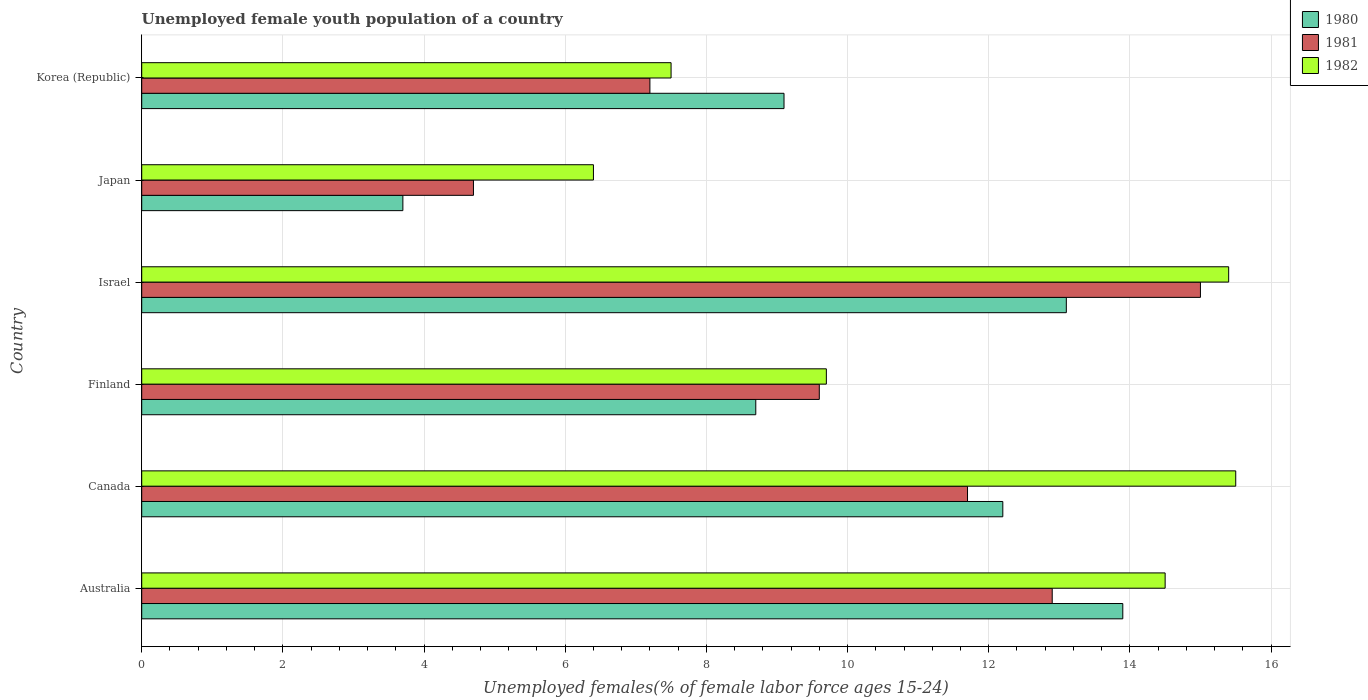How many different coloured bars are there?
Ensure brevity in your answer.  3. How many groups of bars are there?
Your response must be concise. 6. How many bars are there on the 3rd tick from the top?
Offer a very short reply. 3. How many bars are there on the 3rd tick from the bottom?
Your answer should be compact. 3. In how many cases, is the number of bars for a given country not equal to the number of legend labels?
Offer a terse response. 0. What is the percentage of unemployed female youth population in 1981 in Canada?
Offer a very short reply. 11.7. Across all countries, what is the maximum percentage of unemployed female youth population in 1980?
Your response must be concise. 13.9. Across all countries, what is the minimum percentage of unemployed female youth population in 1982?
Your answer should be compact. 6.4. In which country was the percentage of unemployed female youth population in 1982 minimum?
Your answer should be very brief. Japan. What is the total percentage of unemployed female youth population in 1982 in the graph?
Ensure brevity in your answer.  69. What is the difference between the percentage of unemployed female youth population in 1982 in Japan and that in Korea (Republic)?
Your response must be concise. -1.1. What is the difference between the percentage of unemployed female youth population in 1980 in Canada and the percentage of unemployed female youth population in 1982 in Korea (Republic)?
Offer a very short reply. 4.7. What is the average percentage of unemployed female youth population in 1981 per country?
Give a very brief answer. 10.18. In how many countries, is the percentage of unemployed female youth population in 1981 greater than 0.8 %?
Ensure brevity in your answer.  6. What is the ratio of the percentage of unemployed female youth population in 1980 in Japan to that in Korea (Republic)?
Your response must be concise. 0.41. Is the difference between the percentage of unemployed female youth population in 1980 in Canada and Israel greater than the difference between the percentage of unemployed female youth population in 1981 in Canada and Israel?
Provide a short and direct response. Yes. What is the difference between the highest and the second highest percentage of unemployed female youth population in 1982?
Your answer should be compact. 0.1. What is the difference between the highest and the lowest percentage of unemployed female youth population in 1980?
Your response must be concise. 10.2. In how many countries, is the percentage of unemployed female youth population in 1981 greater than the average percentage of unemployed female youth population in 1981 taken over all countries?
Offer a very short reply. 3. Is the sum of the percentage of unemployed female youth population in 1980 in Canada and Japan greater than the maximum percentage of unemployed female youth population in 1982 across all countries?
Offer a very short reply. Yes. What does the 2nd bar from the top in Israel represents?
Give a very brief answer. 1981. Is it the case that in every country, the sum of the percentage of unemployed female youth population in 1980 and percentage of unemployed female youth population in 1982 is greater than the percentage of unemployed female youth population in 1981?
Offer a terse response. Yes. How many bars are there?
Give a very brief answer. 18. How many countries are there in the graph?
Ensure brevity in your answer.  6. Are the values on the major ticks of X-axis written in scientific E-notation?
Keep it short and to the point. No. Does the graph contain any zero values?
Your response must be concise. No. What is the title of the graph?
Keep it short and to the point. Unemployed female youth population of a country. What is the label or title of the X-axis?
Your answer should be very brief. Unemployed females(% of female labor force ages 15-24). What is the Unemployed females(% of female labor force ages 15-24) in 1980 in Australia?
Ensure brevity in your answer.  13.9. What is the Unemployed females(% of female labor force ages 15-24) in 1981 in Australia?
Offer a very short reply. 12.9. What is the Unemployed females(% of female labor force ages 15-24) in 1980 in Canada?
Your answer should be compact. 12.2. What is the Unemployed females(% of female labor force ages 15-24) in 1981 in Canada?
Give a very brief answer. 11.7. What is the Unemployed females(% of female labor force ages 15-24) in 1982 in Canada?
Provide a short and direct response. 15.5. What is the Unemployed females(% of female labor force ages 15-24) of 1980 in Finland?
Provide a succinct answer. 8.7. What is the Unemployed females(% of female labor force ages 15-24) in 1981 in Finland?
Make the answer very short. 9.6. What is the Unemployed females(% of female labor force ages 15-24) of 1982 in Finland?
Your response must be concise. 9.7. What is the Unemployed females(% of female labor force ages 15-24) in 1980 in Israel?
Offer a terse response. 13.1. What is the Unemployed females(% of female labor force ages 15-24) in 1981 in Israel?
Ensure brevity in your answer.  15. What is the Unemployed females(% of female labor force ages 15-24) of 1982 in Israel?
Give a very brief answer. 15.4. What is the Unemployed females(% of female labor force ages 15-24) in 1980 in Japan?
Your response must be concise. 3.7. What is the Unemployed females(% of female labor force ages 15-24) of 1981 in Japan?
Your answer should be compact. 4.7. What is the Unemployed females(% of female labor force ages 15-24) in 1982 in Japan?
Your answer should be compact. 6.4. What is the Unemployed females(% of female labor force ages 15-24) of 1980 in Korea (Republic)?
Provide a succinct answer. 9.1. What is the Unemployed females(% of female labor force ages 15-24) of 1981 in Korea (Republic)?
Provide a short and direct response. 7.2. What is the Unemployed females(% of female labor force ages 15-24) in 1982 in Korea (Republic)?
Keep it short and to the point. 7.5. Across all countries, what is the maximum Unemployed females(% of female labor force ages 15-24) in 1980?
Make the answer very short. 13.9. Across all countries, what is the maximum Unemployed females(% of female labor force ages 15-24) of 1981?
Your response must be concise. 15. Across all countries, what is the maximum Unemployed females(% of female labor force ages 15-24) in 1982?
Offer a very short reply. 15.5. Across all countries, what is the minimum Unemployed females(% of female labor force ages 15-24) of 1980?
Your answer should be compact. 3.7. Across all countries, what is the minimum Unemployed females(% of female labor force ages 15-24) of 1981?
Your answer should be compact. 4.7. Across all countries, what is the minimum Unemployed females(% of female labor force ages 15-24) in 1982?
Your answer should be very brief. 6.4. What is the total Unemployed females(% of female labor force ages 15-24) of 1980 in the graph?
Offer a terse response. 60.7. What is the total Unemployed females(% of female labor force ages 15-24) of 1981 in the graph?
Give a very brief answer. 61.1. What is the difference between the Unemployed females(% of female labor force ages 15-24) in 1980 in Australia and that in Canada?
Provide a succinct answer. 1.7. What is the difference between the Unemployed females(% of female labor force ages 15-24) of 1982 in Australia and that in Canada?
Provide a succinct answer. -1. What is the difference between the Unemployed females(% of female labor force ages 15-24) in 1982 in Australia and that in Finland?
Provide a short and direct response. 4.8. What is the difference between the Unemployed females(% of female labor force ages 15-24) of 1980 in Australia and that in Israel?
Your answer should be compact. 0.8. What is the difference between the Unemployed females(% of female labor force ages 15-24) of 1981 in Australia and that in Israel?
Your answer should be very brief. -2.1. What is the difference between the Unemployed females(% of female labor force ages 15-24) of 1982 in Australia and that in Israel?
Offer a very short reply. -0.9. What is the difference between the Unemployed females(% of female labor force ages 15-24) in 1980 in Australia and that in Japan?
Your answer should be very brief. 10.2. What is the difference between the Unemployed females(% of female labor force ages 15-24) of 1980 in Australia and that in Korea (Republic)?
Offer a very short reply. 4.8. What is the difference between the Unemployed females(% of female labor force ages 15-24) in 1981 in Australia and that in Korea (Republic)?
Offer a very short reply. 5.7. What is the difference between the Unemployed females(% of female labor force ages 15-24) in 1982 in Australia and that in Korea (Republic)?
Provide a short and direct response. 7. What is the difference between the Unemployed females(% of female labor force ages 15-24) in 1980 in Canada and that in Finland?
Your response must be concise. 3.5. What is the difference between the Unemployed females(% of female labor force ages 15-24) of 1980 in Canada and that in Israel?
Ensure brevity in your answer.  -0.9. What is the difference between the Unemployed females(% of female labor force ages 15-24) in 1980 in Canada and that in Japan?
Give a very brief answer. 8.5. What is the difference between the Unemployed females(% of female labor force ages 15-24) of 1981 in Canada and that in Korea (Republic)?
Your answer should be very brief. 4.5. What is the difference between the Unemployed females(% of female labor force ages 15-24) in 1980 in Finland and that in Israel?
Make the answer very short. -4.4. What is the difference between the Unemployed females(% of female labor force ages 15-24) in 1981 in Finland and that in Israel?
Make the answer very short. -5.4. What is the difference between the Unemployed females(% of female labor force ages 15-24) in 1980 in Finland and that in Japan?
Your response must be concise. 5. What is the difference between the Unemployed females(% of female labor force ages 15-24) of 1981 in Finland and that in Japan?
Give a very brief answer. 4.9. What is the difference between the Unemployed females(% of female labor force ages 15-24) in 1982 in Finland and that in Japan?
Make the answer very short. 3.3. What is the difference between the Unemployed females(% of female labor force ages 15-24) in 1982 in Finland and that in Korea (Republic)?
Your response must be concise. 2.2. What is the difference between the Unemployed females(% of female labor force ages 15-24) of 1980 in Israel and that in Japan?
Keep it short and to the point. 9.4. What is the difference between the Unemployed females(% of female labor force ages 15-24) in 1980 in Japan and that in Korea (Republic)?
Your answer should be compact. -5.4. What is the difference between the Unemployed females(% of female labor force ages 15-24) of 1981 in Japan and that in Korea (Republic)?
Offer a terse response. -2.5. What is the difference between the Unemployed females(% of female labor force ages 15-24) in 1982 in Japan and that in Korea (Republic)?
Offer a very short reply. -1.1. What is the difference between the Unemployed females(% of female labor force ages 15-24) in 1980 in Australia and the Unemployed females(% of female labor force ages 15-24) in 1981 in Finland?
Keep it short and to the point. 4.3. What is the difference between the Unemployed females(% of female labor force ages 15-24) in 1981 in Australia and the Unemployed females(% of female labor force ages 15-24) in 1982 in Finland?
Provide a succinct answer. 3.2. What is the difference between the Unemployed females(% of female labor force ages 15-24) of 1981 in Australia and the Unemployed females(% of female labor force ages 15-24) of 1982 in Israel?
Provide a short and direct response. -2.5. What is the difference between the Unemployed females(% of female labor force ages 15-24) in 1980 in Australia and the Unemployed females(% of female labor force ages 15-24) in 1981 in Korea (Republic)?
Give a very brief answer. 6.7. What is the difference between the Unemployed females(% of female labor force ages 15-24) in 1980 in Australia and the Unemployed females(% of female labor force ages 15-24) in 1982 in Korea (Republic)?
Ensure brevity in your answer.  6.4. What is the difference between the Unemployed females(% of female labor force ages 15-24) in 1980 in Canada and the Unemployed females(% of female labor force ages 15-24) in 1981 in Finland?
Your response must be concise. 2.6. What is the difference between the Unemployed females(% of female labor force ages 15-24) in 1980 in Canada and the Unemployed females(% of female labor force ages 15-24) in 1982 in Finland?
Your answer should be compact. 2.5. What is the difference between the Unemployed females(% of female labor force ages 15-24) in 1981 in Canada and the Unemployed females(% of female labor force ages 15-24) in 1982 in Finland?
Your response must be concise. 2. What is the difference between the Unemployed females(% of female labor force ages 15-24) in 1980 in Canada and the Unemployed females(% of female labor force ages 15-24) in 1982 in Israel?
Offer a very short reply. -3.2. What is the difference between the Unemployed females(% of female labor force ages 15-24) of 1981 in Canada and the Unemployed females(% of female labor force ages 15-24) of 1982 in Israel?
Your response must be concise. -3.7. What is the difference between the Unemployed females(% of female labor force ages 15-24) in 1980 in Canada and the Unemployed females(% of female labor force ages 15-24) in 1981 in Japan?
Your response must be concise. 7.5. What is the difference between the Unemployed females(% of female labor force ages 15-24) in 1980 in Canada and the Unemployed females(% of female labor force ages 15-24) in 1982 in Japan?
Keep it short and to the point. 5.8. What is the difference between the Unemployed females(% of female labor force ages 15-24) in 1981 in Canada and the Unemployed females(% of female labor force ages 15-24) in 1982 in Japan?
Your response must be concise. 5.3. What is the difference between the Unemployed females(% of female labor force ages 15-24) in 1980 in Canada and the Unemployed females(% of female labor force ages 15-24) in 1982 in Korea (Republic)?
Offer a very short reply. 4.7. What is the difference between the Unemployed females(% of female labor force ages 15-24) in 1980 in Finland and the Unemployed females(% of female labor force ages 15-24) in 1981 in Israel?
Your answer should be very brief. -6.3. What is the difference between the Unemployed females(% of female labor force ages 15-24) in 1980 in Finland and the Unemployed females(% of female labor force ages 15-24) in 1982 in Israel?
Your answer should be very brief. -6.7. What is the difference between the Unemployed females(% of female labor force ages 15-24) in 1980 in Finland and the Unemployed females(% of female labor force ages 15-24) in 1982 in Japan?
Keep it short and to the point. 2.3. What is the difference between the Unemployed females(% of female labor force ages 15-24) in 1980 in Finland and the Unemployed females(% of female labor force ages 15-24) in 1982 in Korea (Republic)?
Your answer should be very brief. 1.2. What is the difference between the Unemployed females(% of female labor force ages 15-24) of 1980 in Israel and the Unemployed females(% of female labor force ages 15-24) of 1982 in Japan?
Offer a very short reply. 6.7. What is the difference between the Unemployed females(% of female labor force ages 15-24) in 1980 in Israel and the Unemployed females(% of female labor force ages 15-24) in 1982 in Korea (Republic)?
Provide a succinct answer. 5.6. What is the difference between the Unemployed females(% of female labor force ages 15-24) in 1981 in Japan and the Unemployed females(% of female labor force ages 15-24) in 1982 in Korea (Republic)?
Give a very brief answer. -2.8. What is the average Unemployed females(% of female labor force ages 15-24) of 1980 per country?
Your answer should be very brief. 10.12. What is the average Unemployed females(% of female labor force ages 15-24) in 1981 per country?
Your response must be concise. 10.18. What is the average Unemployed females(% of female labor force ages 15-24) of 1982 per country?
Keep it short and to the point. 11.5. What is the difference between the Unemployed females(% of female labor force ages 15-24) in 1980 and Unemployed females(% of female labor force ages 15-24) in 1981 in Australia?
Your response must be concise. 1. What is the difference between the Unemployed females(% of female labor force ages 15-24) in 1980 and Unemployed females(% of female labor force ages 15-24) in 1982 in Australia?
Your answer should be compact. -0.6. What is the difference between the Unemployed females(% of female labor force ages 15-24) in 1980 and Unemployed females(% of female labor force ages 15-24) in 1981 in Canada?
Your answer should be very brief. 0.5. What is the difference between the Unemployed females(% of female labor force ages 15-24) of 1980 and Unemployed females(% of female labor force ages 15-24) of 1982 in Canada?
Provide a short and direct response. -3.3. What is the difference between the Unemployed females(% of female labor force ages 15-24) in 1981 and Unemployed females(% of female labor force ages 15-24) in 1982 in Canada?
Make the answer very short. -3.8. What is the difference between the Unemployed females(% of female labor force ages 15-24) in 1980 and Unemployed females(% of female labor force ages 15-24) in 1981 in Finland?
Offer a terse response. -0.9. What is the difference between the Unemployed females(% of female labor force ages 15-24) of 1980 and Unemployed females(% of female labor force ages 15-24) of 1982 in Finland?
Provide a succinct answer. -1. What is the difference between the Unemployed females(% of female labor force ages 15-24) of 1980 and Unemployed females(% of female labor force ages 15-24) of 1981 in Israel?
Your response must be concise. -1.9. What is the difference between the Unemployed females(% of female labor force ages 15-24) of 1980 and Unemployed females(% of female labor force ages 15-24) of 1982 in Israel?
Your answer should be compact. -2.3. What is the difference between the Unemployed females(% of female labor force ages 15-24) of 1981 and Unemployed females(% of female labor force ages 15-24) of 1982 in Israel?
Offer a terse response. -0.4. What is the difference between the Unemployed females(% of female labor force ages 15-24) of 1980 and Unemployed females(% of female labor force ages 15-24) of 1981 in Japan?
Your answer should be very brief. -1. What is the difference between the Unemployed females(% of female labor force ages 15-24) of 1981 and Unemployed females(% of female labor force ages 15-24) of 1982 in Japan?
Ensure brevity in your answer.  -1.7. What is the difference between the Unemployed females(% of female labor force ages 15-24) of 1980 and Unemployed females(% of female labor force ages 15-24) of 1981 in Korea (Republic)?
Keep it short and to the point. 1.9. What is the difference between the Unemployed females(% of female labor force ages 15-24) of 1980 and Unemployed females(% of female labor force ages 15-24) of 1982 in Korea (Republic)?
Offer a very short reply. 1.6. What is the difference between the Unemployed females(% of female labor force ages 15-24) in 1981 and Unemployed females(% of female labor force ages 15-24) in 1982 in Korea (Republic)?
Keep it short and to the point. -0.3. What is the ratio of the Unemployed females(% of female labor force ages 15-24) in 1980 in Australia to that in Canada?
Provide a short and direct response. 1.14. What is the ratio of the Unemployed females(% of female labor force ages 15-24) of 1981 in Australia to that in Canada?
Your response must be concise. 1.1. What is the ratio of the Unemployed females(% of female labor force ages 15-24) in 1982 in Australia to that in Canada?
Keep it short and to the point. 0.94. What is the ratio of the Unemployed females(% of female labor force ages 15-24) of 1980 in Australia to that in Finland?
Provide a succinct answer. 1.6. What is the ratio of the Unemployed females(% of female labor force ages 15-24) in 1981 in Australia to that in Finland?
Provide a succinct answer. 1.34. What is the ratio of the Unemployed females(% of female labor force ages 15-24) of 1982 in Australia to that in Finland?
Your response must be concise. 1.49. What is the ratio of the Unemployed females(% of female labor force ages 15-24) of 1980 in Australia to that in Israel?
Make the answer very short. 1.06. What is the ratio of the Unemployed females(% of female labor force ages 15-24) in 1981 in Australia to that in Israel?
Provide a short and direct response. 0.86. What is the ratio of the Unemployed females(% of female labor force ages 15-24) in 1982 in Australia to that in Israel?
Provide a short and direct response. 0.94. What is the ratio of the Unemployed females(% of female labor force ages 15-24) in 1980 in Australia to that in Japan?
Give a very brief answer. 3.76. What is the ratio of the Unemployed females(% of female labor force ages 15-24) in 1981 in Australia to that in Japan?
Offer a terse response. 2.74. What is the ratio of the Unemployed females(% of female labor force ages 15-24) in 1982 in Australia to that in Japan?
Your response must be concise. 2.27. What is the ratio of the Unemployed females(% of female labor force ages 15-24) in 1980 in Australia to that in Korea (Republic)?
Provide a short and direct response. 1.53. What is the ratio of the Unemployed females(% of female labor force ages 15-24) of 1981 in Australia to that in Korea (Republic)?
Make the answer very short. 1.79. What is the ratio of the Unemployed females(% of female labor force ages 15-24) in 1982 in Australia to that in Korea (Republic)?
Your response must be concise. 1.93. What is the ratio of the Unemployed females(% of female labor force ages 15-24) in 1980 in Canada to that in Finland?
Make the answer very short. 1.4. What is the ratio of the Unemployed females(% of female labor force ages 15-24) of 1981 in Canada to that in Finland?
Provide a succinct answer. 1.22. What is the ratio of the Unemployed females(% of female labor force ages 15-24) in 1982 in Canada to that in Finland?
Keep it short and to the point. 1.6. What is the ratio of the Unemployed females(% of female labor force ages 15-24) in 1980 in Canada to that in Israel?
Your answer should be very brief. 0.93. What is the ratio of the Unemployed females(% of female labor force ages 15-24) in 1981 in Canada to that in Israel?
Keep it short and to the point. 0.78. What is the ratio of the Unemployed females(% of female labor force ages 15-24) of 1982 in Canada to that in Israel?
Make the answer very short. 1.01. What is the ratio of the Unemployed females(% of female labor force ages 15-24) in 1980 in Canada to that in Japan?
Your answer should be compact. 3.3. What is the ratio of the Unemployed females(% of female labor force ages 15-24) in 1981 in Canada to that in Japan?
Your response must be concise. 2.49. What is the ratio of the Unemployed females(% of female labor force ages 15-24) in 1982 in Canada to that in Japan?
Provide a short and direct response. 2.42. What is the ratio of the Unemployed females(% of female labor force ages 15-24) of 1980 in Canada to that in Korea (Republic)?
Offer a terse response. 1.34. What is the ratio of the Unemployed females(% of female labor force ages 15-24) of 1981 in Canada to that in Korea (Republic)?
Provide a succinct answer. 1.62. What is the ratio of the Unemployed females(% of female labor force ages 15-24) of 1982 in Canada to that in Korea (Republic)?
Ensure brevity in your answer.  2.07. What is the ratio of the Unemployed females(% of female labor force ages 15-24) of 1980 in Finland to that in Israel?
Make the answer very short. 0.66. What is the ratio of the Unemployed females(% of female labor force ages 15-24) in 1981 in Finland to that in Israel?
Give a very brief answer. 0.64. What is the ratio of the Unemployed females(% of female labor force ages 15-24) of 1982 in Finland to that in Israel?
Your answer should be compact. 0.63. What is the ratio of the Unemployed females(% of female labor force ages 15-24) of 1980 in Finland to that in Japan?
Make the answer very short. 2.35. What is the ratio of the Unemployed females(% of female labor force ages 15-24) in 1981 in Finland to that in Japan?
Provide a short and direct response. 2.04. What is the ratio of the Unemployed females(% of female labor force ages 15-24) in 1982 in Finland to that in Japan?
Your answer should be very brief. 1.52. What is the ratio of the Unemployed females(% of female labor force ages 15-24) of 1980 in Finland to that in Korea (Republic)?
Offer a terse response. 0.96. What is the ratio of the Unemployed females(% of female labor force ages 15-24) in 1981 in Finland to that in Korea (Republic)?
Make the answer very short. 1.33. What is the ratio of the Unemployed females(% of female labor force ages 15-24) in 1982 in Finland to that in Korea (Republic)?
Make the answer very short. 1.29. What is the ratio of the Unemployed females(% of female labor force ages 15-24) in 1980 in Israel to that in Japan?
Give a very brief answer. 3.54. What is the ratio of the Unemployed females(% of female labor force ages 15-24) of 1981 in Israel to that in Japan?
Provide a short and direct response. 3.19. What is the ratio of the Unemployed females(% of female labor force ages 15-24) of 1982 in Israel to that in Japan?
Your answer should be compact. 2.41. What is the ratio of the Unemployed females(% of female labor force ages 15-24) of 1980 in Israel to that in Korea (Republic)?
Provide a succinct answer. 1.44. What is the ratio of the Unemployed females(% of female labor force ages 15-24) of 1981 in Israel to that in Korea (Republic)?
Offer a very short reply. 2.08. What is the ratio of the Unemployed females(% of female labor force ages 15-24) of 1982 in Israel to that in Korea (Republic)?
Provide a succinct answer. 2.05. What is the ratio of the Unemployed females(% of female labor force ages 15-24) in 1980 in Japan to that in Korea (Republic)?
Ensure brevity in your answer.  0.41. What is the ratio of the Unemployed females(% of female labor force ages 15-24) of 1981 in Japan to that in Korea (Republic)?
Your answer should be very brief. 0.65. What is the ratio of the Unemployed females(% of female labor force ages 15-24) of 1982 in Japan to that in Korea (Republic)?
Provide a short and direct response. 0.85. What is the difference between the highest and the second highest Unemployed females(% of female labor force ages 15-24) of 1980?
Your answer should be very brief. 0.8. What is the difference between the highest and the lowest Unemployed females(% of female labor force ages 15-24) of 1980?
Your answer should be very brief. 10.2. 